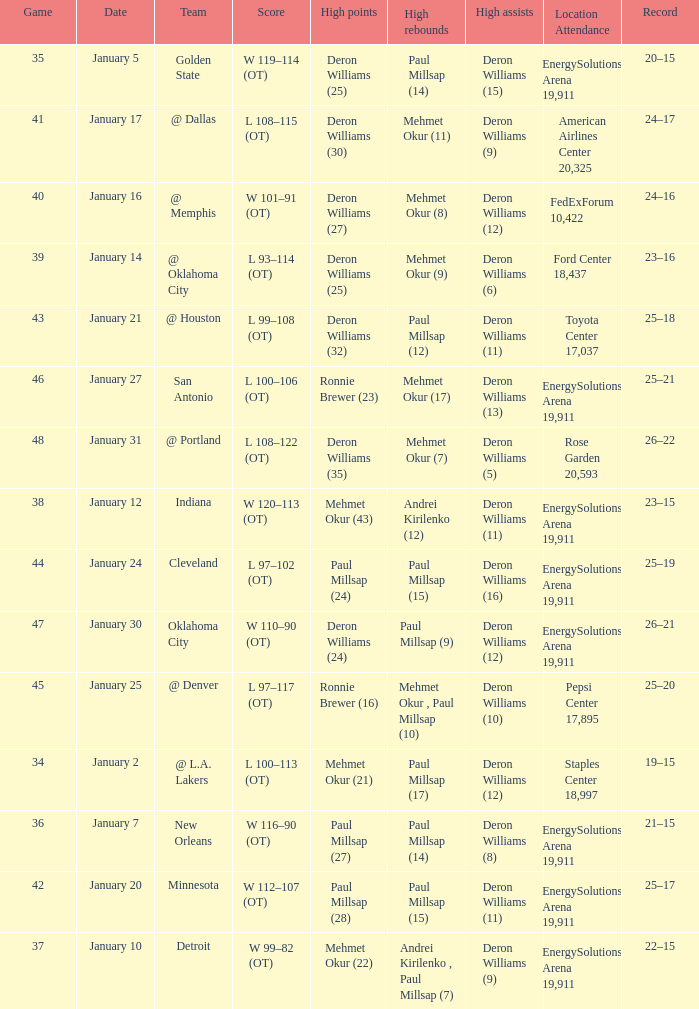Who had the high rebounds of the game that Deron Williams (5) had the high assists? Mehmet Okur (7). 